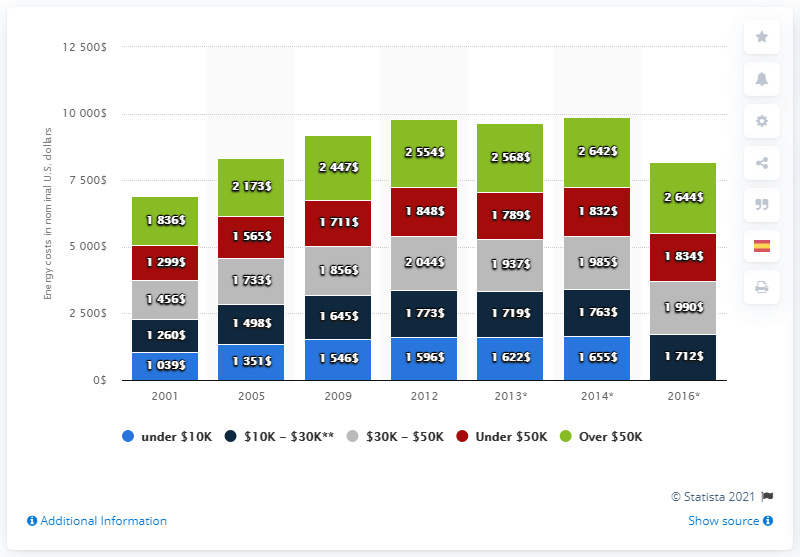Highlight a few significant elements in this photo. The result of subtracting 1000 from all the data in the 2001 dataset and then summing the resulting values is 1890. The given information represents a sequence of yearly data points from 1351 to 2005. To find the year for each data point, we need to use the information given. 